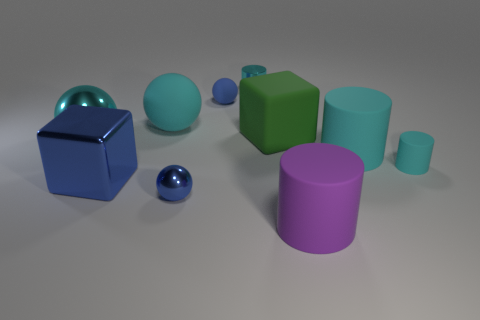Subtract all cyan cylinders. How many were subtracted if there are2cyan cylinders left? 1 Subtract all big cyan matte cylinders. How many cylinders are left? 3 Subtract all cyan cylinders. How many cylinders are left? 1 Subtract 1 cubes. How many cubes are left? 1 Subtract all spheres. How many objects are left? 6 Subtract all gray cubes. How many purple balls are left? 0 Subtract all small matte things. Subtract all tiny spheres. How many objects are left? 6 Add 9 tiny blue rubber objects. How many tiny blue rubber objects are left? 10 Add 7 tiny cylinders. How many tiny cylinders exist? 9 Subtract 0 red blocks. How many objects are left? 10 